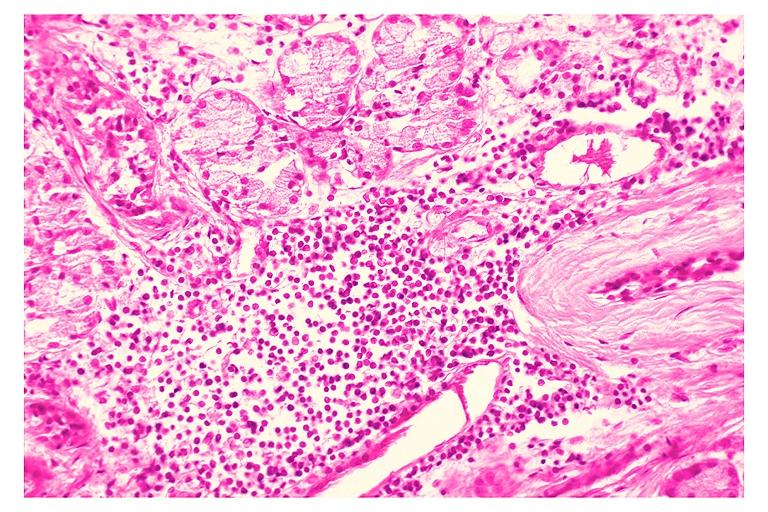where is this?
Answer the question using a single word or phrase. Oral 